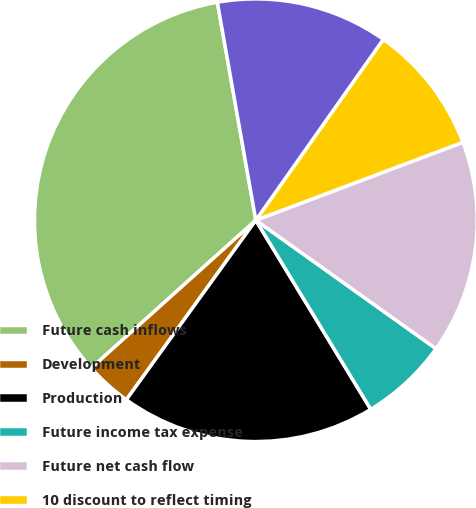Convert chart. <chart><loc_0><loc_0><loc_500><loc_500><pie_chart><fcel>Future cash inflows<fcel>Development<fcel>Production<fcel>Future income tax expense<fcel>Future net cash flow<fcel>10 discount to reflect timing<fcel>Standardized measure of<nl><fcel>33.87%<fcel>3.41%<fcel>18.64%<fcel>6.45%<fcel>15.59%<fcel>9.5%<fcel>12.55%<nl></chart> 